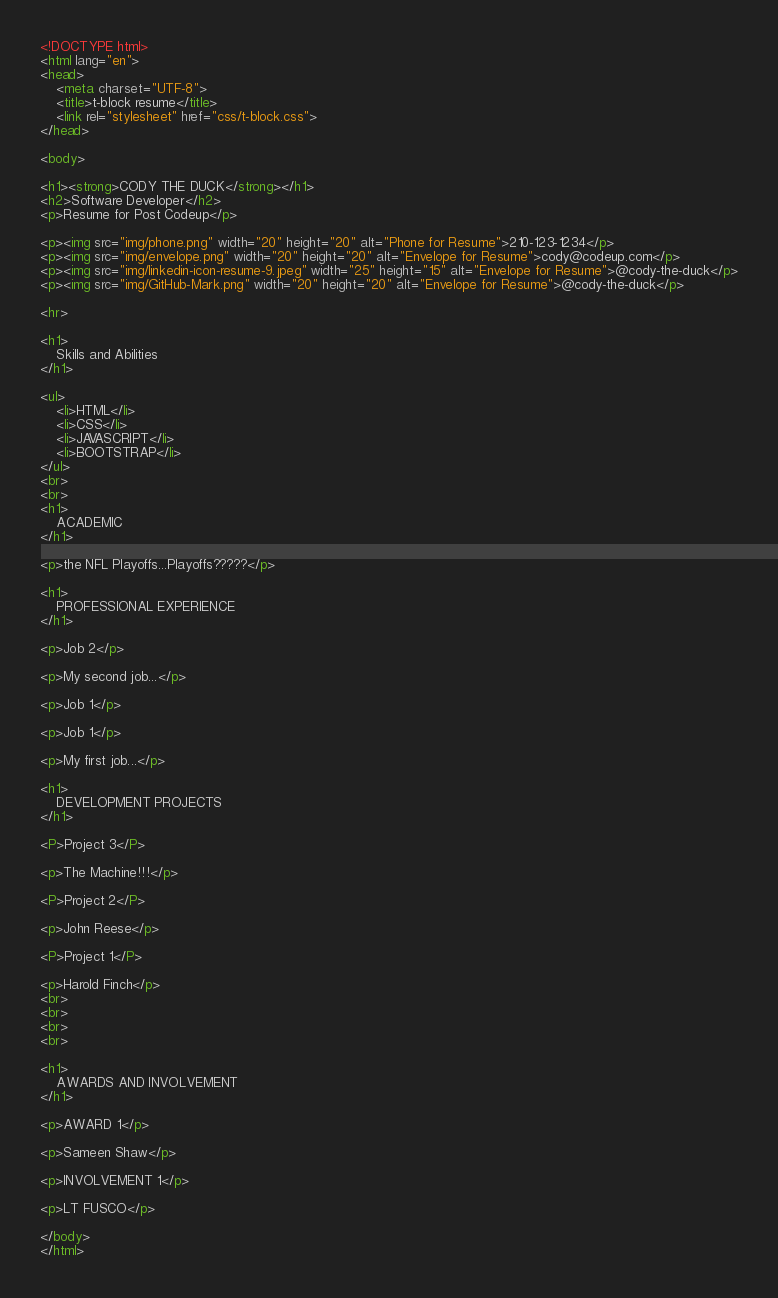Convert code to text. <code><loc_0><loc_0><loc_500><loc_500><_HTML_><!DOCTYPE html>
<html lang="en">
<head>
    <meta charset="UTF-8">
    <title>t-block resume</title>
    <link rel="stylesheet" href="css/t-block.css">
</head>

<body>

<h1><strong>CODY THE DUCK</strong></h1>
<h2>Software Developer</h2>
<p>Resume for Post Codeup</p>

<p><img src="img/phone.png" width="20" height="20" alt="Phone for Resume">210-123-1234</p>
<p><img src="img/envelope.png" width="20" height="20" alt="Envelope for Resume">cody@codeup.com</p>
<p><img src="img/linkedin-icon-resume-9.jpeg" width="25" height="15" alt="Envelope for Resume">@cody-the-duck</p>
<p><img src="img/GitHub-Mark.png" width="20" height="20" alt="Envelope for Resume">@cody-the-duck</p>

<hr>

<h1>
    Skills and Abilities
</h1>

<ul>
    <li>HTML</li>
    <li>CSS</li>
    <li>JAVASCRIPT</li>
    <li>BOOTSTRAP</li>
</ul>
<br>
<br>
<h1>
    ACADEMIC
</h1>

<p>the NFL Playoffs...Playoffs?????</p>

<h1>
    PROFESSIONAL EXPERIENCE
</h1>

<p>Job 2</p>

<p>My second job...</p>

<p>Job 1</p>

<p>Job 1</p>

<p>My first job...</p>

<h1>
    DEVELOPMENT PROJECTS
</h1>

<P>Project 3</P>

<p>The Machine!!!</p>

<P>Project 2</P>

<p>John Reese</p>

<P>Project 1</P>

<p>Harold Finch</p>
<br>
<br>
<br>
<br>

<h1>
    AWARDS AND INVOLVEMENT
</h1>

<p>AWARD 1</p>

<p>Sameen Shaw</p>

<p>INVOLVEMENT 1</p>

<p>LT FUSCO</p>

</body>
</html></code> 